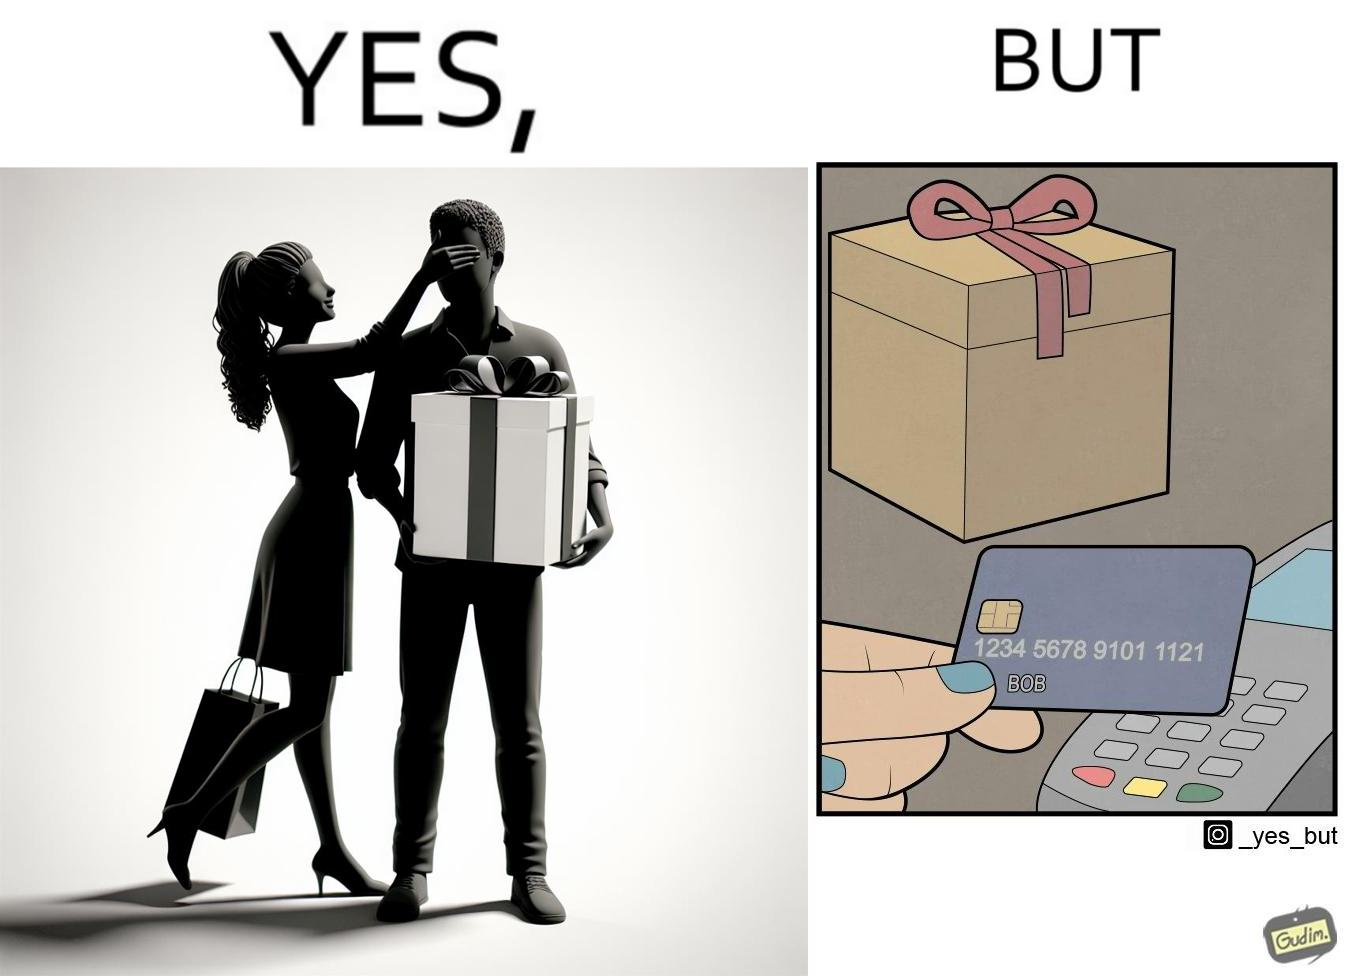What is shown in this image? The image is ironical, as a woman is gifting something to a person named Bob, while using Bob's card itself to purchase the gift. 